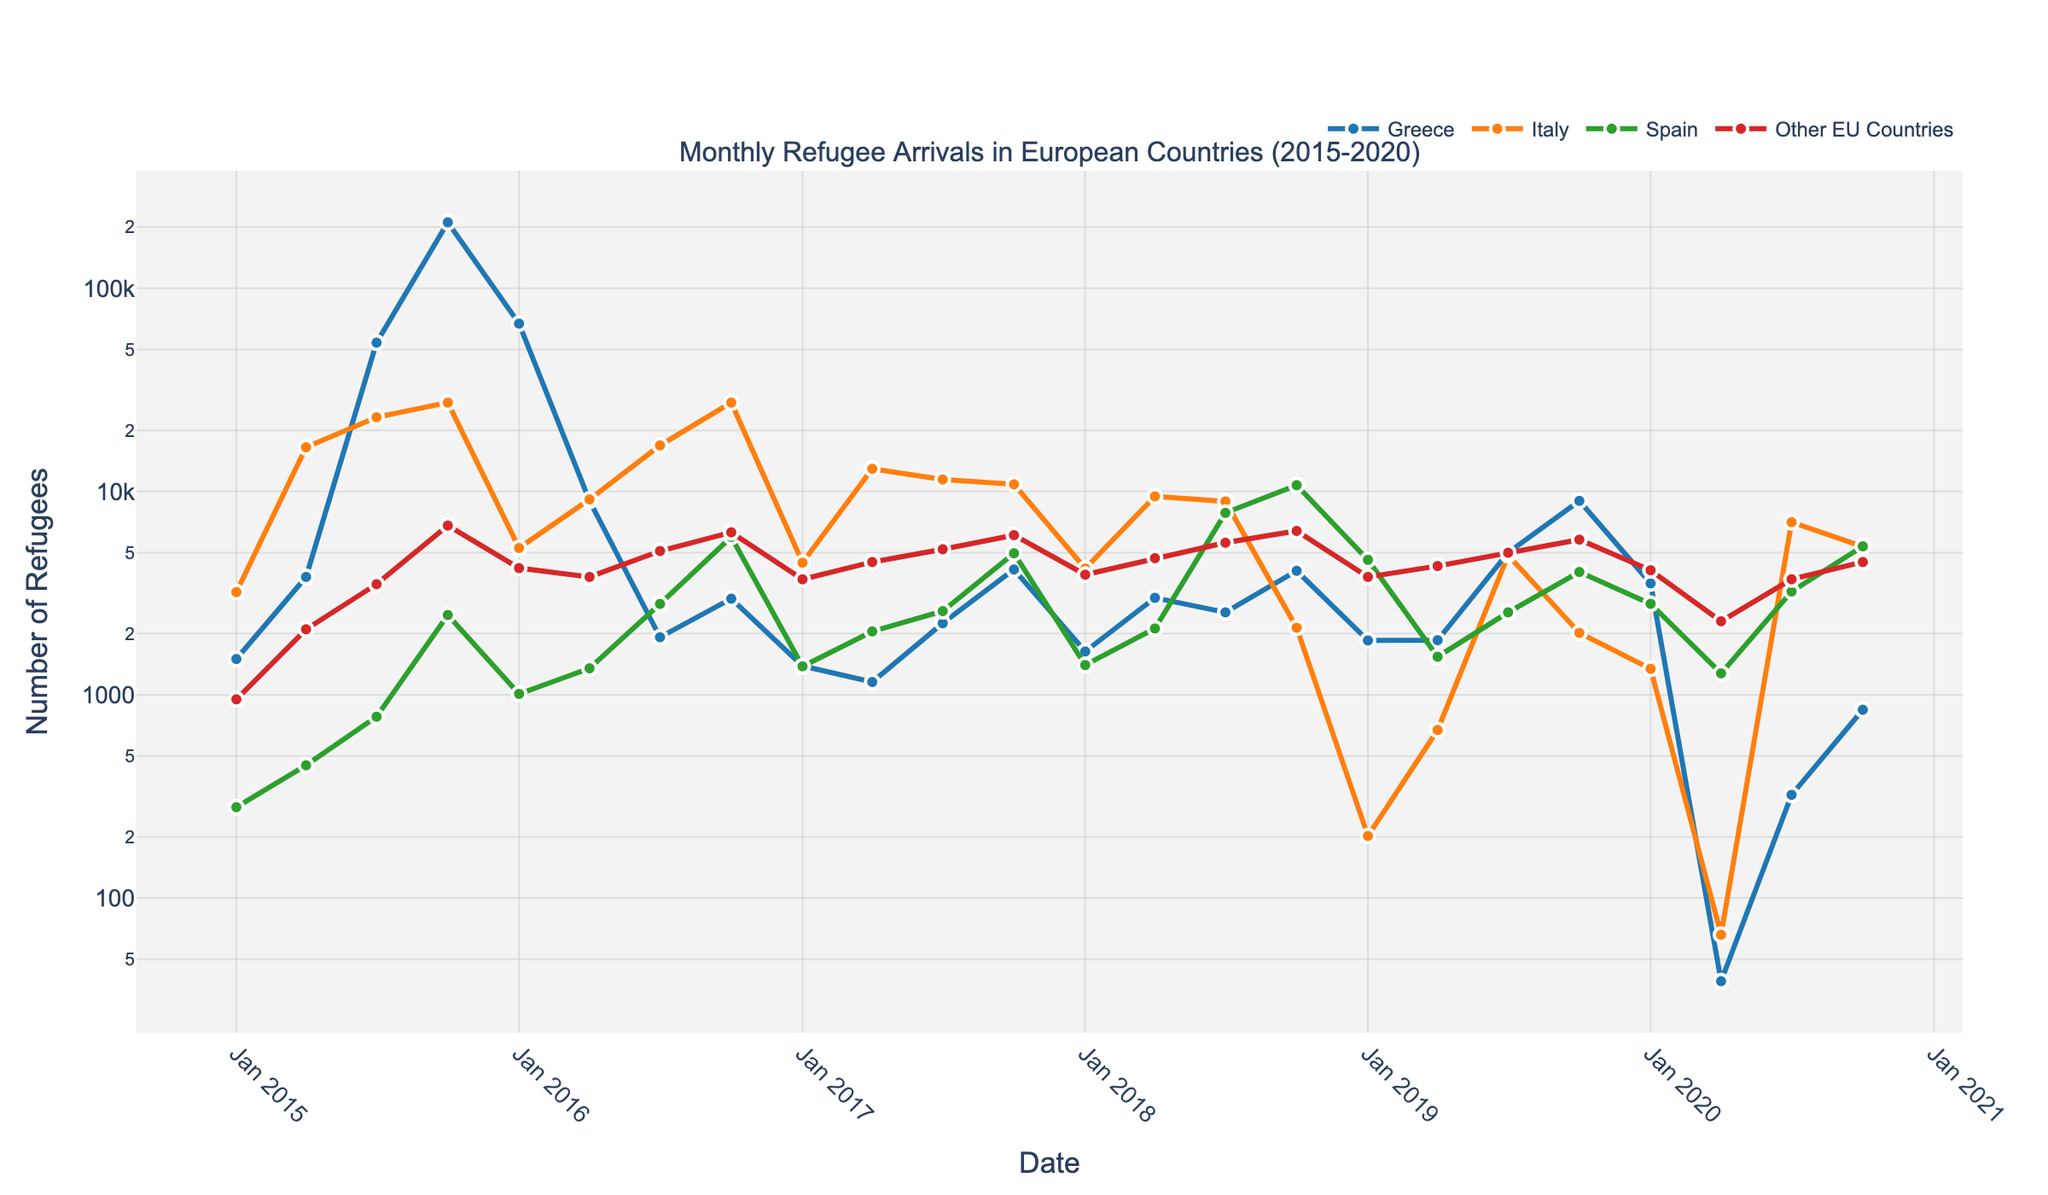What was the trend in refugee arrivals in Greece during the period 2015-2016? The line chart shows that arrivals in Greece peaked in October 2015 at 211,000, followed by a sharp decline through 2016, reaching 1,920 by July 2016.
Answer: A sharp rise and then a steep decline Which EU country had the highest peak of refugee arrivals and when? Greece had the highest peak of refugee arrivals in October 2015, with 211,000 arrivals.
Answer: Greece in October 2015 What was the general trend for refugee arrivals in Italy from 2015 to 2017? The trend in Italy's refugee arrivals shows significant fluctuations, with peaks in April 2015 and July 2016, and gradually decreasing from mid-2017 onwards.
Answer: Fluctuating with a general decrease from mid-2017 When did Spain see the highest number of refugee arrivals and how many were there? Spain saw the highest number of refugee arrivals in October 2018, with 10,748 arrivals.
Answer: October 2018, 10,748 arrivals Compare the refugee arrivals in Greece and Italy in January 2016. In January 2016, Greece had 67,000 refugee arrivals and Italy had 5,273.
Answer: Greece had significantly more arrivals What was the average monthly refugee arrivals in Spain for the year 2018? Sum the monthly values for Spain in 2018 and divide by 12. (1400 + 2120 + 7855 + 10748) / 4 = 5,031
Answer: 5,031 Between which two consecutive quarters did Italy experience the greatest drop in refugee arrivals? The greatest drop in Italy's figures occurred between October 2018 (2,137) and January 2019 (202), a difference of 1,935.
Answer: Between October 2018 and January 2019 By how much did the refugee arrivals in Greece differ between January 2015 and October 2019? Subtract the January 2015 value from October 2019 value: 8996 - 1500 = 7496
Answer: 7,496 Which country had the most consistent number of arrivals from 2015 to 2020, considering the volatility of arrival numbers? Referring to the plot, "Other EU Countries" shows less dramatic fluctuations and a more consistent trend compared to Greece, Italy, and Spain.
Answer: Other EU Countries 